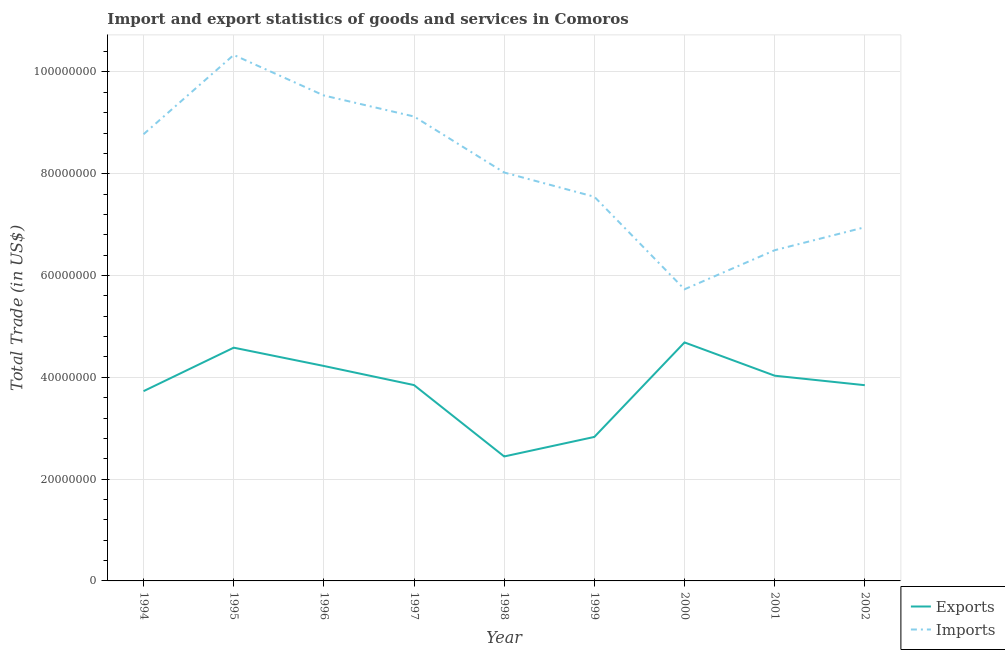Is the number of lines equal to the number of legend labels?
Offer a terse response. Yes. What is the export of goods and services in 1997?
Your answer should be very brief. 3.85e+07. Across all years, what is the maximum imports of goods and services?
Make the answer very short. 1.03e+08. Across all years, what is the minimum imports of goods and services?
Give a very brief answer. 5.73e+07. In which year was the export of goods and services maximum?
Offer a very short reply. 2000. What is the total export of goods and services in the graph?
Offer a very short reply. 3.42e+08. What is the difference between the imports of goods and services in 1999 and that in 2000?
Your answer should be compact. 1.82e+07. What is the difference between the export of goods and services in 1997 and the imports of goods and services in 2002?
Ensure brevity in your answer.  -3.10e+07. What is the average export of goods and services per year?
Keep it short and to the point. 3.80e+07. In the year 2002, what is the difference between the imports of goods and services and export of goods and services?
Your response must be concise. 3.10e+07. What is the ratio of the export of goods and services in 1996 to that in 2000?
Provide a short and direct response. 0.9. Is the imports of goods and services in 1999 less than that in 2001?
Offer a very short reply. No. What is the difference between the highest and the second highest imports of goods and services?
Offer a very short reply. 7.97e+06. What is the difference between the highest and the lowest export of goods and services?
Your response must be concise. 2.24e+07. In how many years, is the imports of goods and services greater than the average imports of goods and services taken over all years?
Keep it short and to the point. 4. Is the sum of the export of goods and services in 1997 and 2000 greater than the maximum imports of goods and services across all years?
Your answer should be compact. No. Is the export of goods and services strictly greater than the imports of goods and services over the years?
Your answer should be very brief. No. Is the imports of goods and services strictly less than the export of goods and services over the years?
Keep it short and to the point. No. How many lines are there?
Your response must be concise. 2. What is the difference between two consecutive major ticks on the Y-axis?
Make the answer very short. 2.00e+07. Are the values on the major ticks of Y-axis written in scientific E-notation?
Make the answer very short. No. Does the graph contain any zero values?
Provide a short and direct response. No. How many legend labels are there?
Provide a short and direct response. 2. What is the title of the graph?
Keep it short and to the point. Import and export statistics of goods and services in Comoros. What is the label or title of the Y-axis?
Give a very brief answer. Total Trade (in US$). What is the Total Trade (in US$) in Exports in 1994?
Ensure brevity in your answer.  3.73e+07. What is the Total Trade (in US$) in Imports in 1994?
Your answer should be very brief. 8.78e+07. What is the Total Trade (in US$) in Exports in 1995?
Ensure brevity in your answer.  4.58e+07. What is the Total Trade (in US$) of Imports in 1995?
Give a very brief answer. 1.03e+08. What is the Total Trade (in US$) of Exports in 1996?
Offer a terse response. 4.22e+07. What is the Total Trade (in US$) of Imports in 1996?
Your answer should be compact. 9.54e+07. What is the Total Trade (in US$) in Exports in 1997?
Make the answer very short. 3.85e+07. What is the Total Trade (in US$) of Imports in 1997?
Give a very brief answer. 9.13e+07. What is the Total Trade (in US$) in Exports in 1998?
Ensure brevity in your answer.  2.45e+07. What is the Total Trade (in US$) in Imports in 1998?
Your response must be concise. 8.02e+07. What is the Total Trade (in US$) in Exports in 1999?
Provide a short and direct response. 2.83e+07. What is the Total Trade (in US$) of Imports in 1999?
Your answer should be compact. 7.55e+07. What is the Total Trade (in US$) in Exports in 2000?
Offer a terse response. 4.69e+07. What is the Total Trade (in US$) in Imports in 2000?
Provide a succinct answer. 5.73e+07. What is the Total Trade (in US$) in Exports in 2001?
Keep it short and to the point. 4.03e+07. What is the Total Trade (in US$) in Imports in 2001?
Ensure brevity in your answer.  6.50e+07. What is the Total Trade (in US$) in Exports in 2002?
Give a very brief answer. 3.85e+07. What is the Total Trade (in US$) of Imports in 2002?
Ensure brevity in your answer.  6.95e+07. Across all years, what is the maximum Total Trade (in US$) in Exports?
Give a very brief answer. 4.69e+07. Across all years, what is the maximum Total Trade (in US$) of Imports?
Offer a terse response. 1.03e+08. Across all years, what is the minimum Total Trade (in US$) in Exports?
Provide a short and direct response. 2.45e+07. Across all years, what is the minimum Total Trade (in US$) of Imports?
Keep it short and to the point. 5.73e+07. What is the total Total Trade (in US$) in Exports in the graph?
Your response must be concise. 3.42e+08. What is the total Total Trade (in US$) of Imports in the graph?
Offer a terse response. 7.25e+08. What is the difference between the Total Trade (in US$) in Exports in 1994 and that in 1995?
Provide a succinct answer. -8.54e+06. What is the difference between the Total Trade (in US$) in Imports in 1994 and that in 1995?
Provide a succinct answer. -1.56e+07. What is the difference between the Total Trade (in US$) of Exports in 1994 and that in 1996?
Keep it short and to the point. -4.95e+06. What is the difference between the Total Trade (in US$) in Imports in 1994 and that in 1996?
Your response must be concise. -7.61e+06. What is the difference between the Total Trade (in US$) in Exports in 1994 and that in 1997?
Offer a very short reply. -1.19e+06. What is the difference between the Total Trade (in US$) in Imports in 1994 and that in 1997?
Give a very brief answer. -3.48e+06. What is the difference between the Total Trade (in US$) of Exports in 1994 and that in 1998?
Your answer should be very brief. 1.28e+07. What is the difference between the Total Trade (in US$) of Imports in 1994 and that in 1998?
Your response must be concise. 7.52e+06. What is the difference between the Total Trade (in US$) of Exports in 1994 and that in 1999?
Offer a very short reply. 9.00e+06. What is the difference between the Total Trade (in US$) of Imports in 1994 and that in 1999?
Your answer should be very brief. 1.23e+07. What is the difference between the Total Trade (in US$) in Exports in 1994 and that in 2000?
Your response must be concise. -9.57e+06. What is the difference between the Total Trade (in US$) in Imports in 1994 and that in 2000?
Keep it short and to the point. 3.05e+07. What is the difference between the Total Trade (in US$) in Exports in 1994 and that in 2001?
Keep it short and to the point. -3.04e+06. What is the difference between the Total Trade (in US$) of Imports in 1994 and that in 2001?
Provide a short and direct response. 2.28e+07. What is the difference between the Total Trade (in US$) in Exports in 1994 and that in 2002?
Ensure brevity in your answer.  -1.17e+06. What is the difference between the Total Trade (in US$) in Imports in 1994 and that in 2002?
Your answer should be compact. 1.83e+07. What is the difference between the Total Trade (in US$) of Exports in 1995 and that in 1996?
Make the answer very short. 3.60e+06. What is the difference between the Total Trade (in US$) in Imports in 1995 and that in 1996?
Your answer should be very brief. 7.97e+06. What is the difference between the Total Trade (in US$) in Exports in 1995 and that in 1997?
Ensure brevity in your answer.  7.35e+06. What is the difference between the Total Trade (in US$) in Imports in 1995 and that in 1997?
Offer a very short reply. 1.21e+07. What is the difference between the Total Trade (in US$) of Exports in 1995 and that in 1998?
Ensure brevity in your answer.  2.14e+07. What is the difference between the Total Trade (in US$) in Imports in 1995 and that in 1998?
Offer a very short reply. 2.31e+07. What is the difference between the Total Trade (in US$) in Exports in 1995 and that in 1999?
Keep it short and to the point. 1.75e+07. What is the difference between the Total Trade (in US$) of Imports in 1995 and that in 1999?
Your answer should be very brief. 2.79e+07. What is the difference between the Total Trade (in US$) of Exports in 1995 and that in 2000?
Offer a terse response. -1.03e+06. What is the difference between the Total Trade (in US$) of Imports in 1995 and that in 2000?
Your response must be concise. 4.60e+07. What is the difference between the Total Trade (in US$) in Exports in 1995 and that in 2001?
Offer a very short reply. 5.51e+06. What is the difference between the Total Trade (in US$) in Imports in 1995 and that in 2001?
Your answer should be compact. 3.84e+07. What is the difference between the Total Trade (in US$) in Exports in 1995 and that in 2002?
Provide a succinct answer. 7.37e+06. What is the difference between the Total Trade (in US$) of Imports in 1995 and that in 2002?
Provide a short and direct response. 3.39e+07. What is the difference between the Total Trade (in US$) of Exports in 1996 and that in 1997?
Offer a terse response. 3.75e+06. What is the difference between the Total Trade (in US$) in Imports in 1996 and that in 1997?
Your answer should be very brief. 4.13e+06. What is the difference between the Total Trade (in US$) of Exports in 1996 and that in 1998?
Offer a very short reply. 1.78e+07. What is the difference between the Total Trade (in US$) in Imports in 1996 and that in 1998?
Your response must be concise. 1.51e+07. What is the difference between the Total Trade (in US$) of Exports in 1996 and that in 1999?
Offer a terse response. 1.39e+07. What is the difference between the Total Trade (in US$) in Imports in 1996 and that in 1999?
Give a very brief answer. 1.99e+07. What is the difference between the Total Trade (in US$) in Exports in 1996 and that in 2000?
Your answer should be compact. -4.63e+06. What is the difference between the Total Trade (in US$) of Imports in 1996 and that in 2000?
Your answer should be very brief. 3.81e+07. What is the difference between the Total Trade (in US$) in Exports in 1996 and that in 2001?
Your answer should be very brief. 1.91e+06. What is the difference between the Total Trade (in US$) in Imports in 1996 and that in 2001?
Offer a terse response. 3.04e+07. What is the difference between the Total Trade (in US$) in Exports in 1996 and that in 2002?
Offer a terse response. 3.78e+06. What is the difference between the Total Trade (in US$) of Imports in 1996 and that in 2002?
Your answer should be very brief. 2.59e+07. What is the difference between the Total Trade (in US$) in Exports in 1997 and that in 1998?
Your answer should be very brief. 1.40e+07. What is the difference between the Total Trade (in US$) in Imports in 1997 and that in 1998?
Make the answer very short. 1.10e+07. What is the difference between the Total Trade (in US$) of Exports in 1997 and that in 1999?
Provide a succinct answer. 1.02e+07. What is the difference between the Total Trade (in US$) of Imports in 1997 and that in 1999?
Provide a succinct answer. 1.58e+07. What is the difference between the Total Trade (in US$) of Exports in 1997 and that in 2000?
Make the answer very short. -8.38e+06. What is the difference between the Total Trade (in US$) in Imports in 1997 and that in 2000?
Ensure brevity in your answer.  3.40e+07. What is the difference between the Total Trade (in US$) in Exports in 1997 and that in 2001?
Offer a terse response. -1.84e+06. What is the difference between the Total Trade (in US$) in Imports in 1997 and that in 2001?
Give a very brief answer. 2.63e+07. What is the difference between the Total Trade (in US$) in Exports in 1997 and that in 2002?
Give a very brief answer. 2.23e+04. What is the difference between the Total Trade (in US$) in Imports in 1997 and that in 2002?
Offer a terse response. 2.18e+07. What is the difference between the Total Trade (in US$) in Exports in 1998 and that in 1999?
Offer a very short reply. -3.84e+06. What is the difference between the Total Trade (in US$) in Imports in 1998 and that in 1999?
Provide a succinct answer. 4.76e+06. What is the difference between the Total Trade (in US$) of Exports in 1998 and that in 2000?
Ensure brevity in your answer.  -2.24e+07. What is the difference between the Total Trade (in US$) in Imports in 1998 and that in 2000?
Give a very brief answer. 2.29e+07. What is the difference between the Total Trade (in US$) in Exports in 1998 and that in 2001?
Keep it short and to the point. -1.59e+07. What is the difference between the Total Trade (in US$) of Imports in 1998 and that in 2001?
Keep it short and to the point. 1.53e+07. What is the difference between the Total Trade (in US$) in Exports in 1998 and that in 2002?
Make the answer very short. -1.40e+07. What is the difference between the Total Trade (in US$) of Imports in 1998 and that in 2002?
Your answer should be very brief. 1.08e+07. What is the difference between the Total Trade (in US$) in Exports in 1999 and that in 2000?
Offer a terse response. -1.86e+07. What is the difference between the Total Trade (in US$) in Imports in 1999 and that in 2000?
Offer a very short reply. 1.82e+07. What is the difference between the Total Trade (in US$) in Exports in 1999 and that in 2001?
Your answer should be compact. -1.20e+07. What is the difference between the Total Trade (in US$) of Imports in 1999 and that in 2001?
Your response must be concise. 1.05e+07. What is the difference between the Total Trade (in US$) of Exports in 1999 and that in 2002?
Give a very brief answer. -1.02e+07. What is the difference between the Total Trade (in US$) of Imports in 1999 and that in 2002?
Your answer should be very brief. 5.99e+06. What is the difference between the Total Trade (in US$) of Exports in 2000 and that in 2001?
Offer a terse response. 6.54e+06. What is the difference between the Total Trade (in US$) of Imports in 2000 and that in 2001?
Give a very brief answer. -7.68e+06. What is the difference between the Total Trade (in US$) in Exports in 2000 and that in 2002?
Give a very brief answer. 8.40e+06. What is the difference between the Total Trade (in US$) of Imports in 2000 and that in 2002?
Provide a succinct answer. -1.22e+07. What is the difference between the Total Trade (in US$) in Exports in 2001 and that in 2002?
Your answer should be compact. 1.87e+06. What is the difference between the Total Trade (in US$) of Imports in 2001 and that in 2002?
Keep it short and to the point. -4.51e+06. What is the difference between the Total Trade (in US$) of Exports in 1994 and the Total Trade (in US$) of Imports in 1995?
Provide a succinct answer. -6.61e+07. What is the difference between the Total Trade (in US$) in Exports in 1994 and the Total Trade (in US$) in Imports in 1996?
Offer a terse response. -5.81e+07. What is the difference between the Total Trade (in US$) of Exports in 1994 and the Total Trade (in US$) of Imports in 1997?
Ensure brevity in your answer.  -5.40e+07. What is the difference between the Total Trade (in US$) in Exports in 1994 and the Total Trade (in US$) in Imports in 1998?
Your answer should be compact. -4.30e+07. What is the difference between the Total Trade (in US$) of Exports in 1994 and the Total Trade (in US$) of Imports in 1999?
Ensure brevity in your answer.  -3.82e+07. What is the difference between the Total Trade (in US$) of Exports in 1994 and the Total Trade (in US$) of Imports in 2000?
Keep it short and to the point. -2.00e+07. What is the difference between the Total Trade (in US$) of Exports in 1994 and the Total Trade (in US$) of Imports in 2001?
Provide a succinct answer. -2.77e+07. What is the difference between the Total Trade (in US$) in Exports in 1994 and the Total Trade (in US$) in Imports in 2002?
Offer a terse response. -3.22e+07. What is the difference between the Total Trade (in US$) of Exports in 1995 and the Total Trade (in US$) of Imports in 1996?
Provide a short and direct response. -4.96e+07. What is the difference between the Total Trade (in US$) of Exports in 1995 and the Total Trade (in US$) of Imports in 1997?
Provide a short and direct response. -4.54e+07. What is the difference between the Total Trade (in US$) in Exports in 1995 and the Total Trade (in US$) in Imports in 1998?
Your response must be concise. -3.44e+07. What is the difference between the Total Trade (in US$) in Exports in 1995 and the Total Trade (in US$) in Imports in 1999?
Ensure brevity in your answer.  -2.97e+07. What is the difference between the Total Trade (in US$) in Exports in 1995 and the Total Trade (in US$) in Imports in 2000?
Give a very brief answer. -1.15e+07. What is the difference between the Total Trade (in US$) of Exports in 1995 and the Total Trade (in US$) of Imports in 2001?
Make the answer very short. -1.91e+07. What is the difference between the Total Trade (in US$) in Exports in 1995 and the Total Trade (in US$) in Imports in 2002?
Keep it short and to the point. -2.37e+07. What is the difference between the Total Trade (in US$) of Exports in 1996 and the Total Trade (in US$) of Imports in 1997?
Provide a short and direct response. -4.90e+07. What is the difference between the Total Trade (in US$) of Exports in 1996 and the Total Trade (in US$) of Imports in 1998?
Provide a short and direct response. -3.80e+07. What is the difference between the Total Trade (in US$) of Exports in 1996 and the Total Trade (in US$) of Imports in 1999?
Offer a terse response. -3.32e+07. What is the difference between the Total Trade (in US$) of Exports in 1996 and the Total Trade (in US$) of Imports in 2000?
Offer a terse response. -1.51e+07. What is the difference between the Total Trade (in US$) in Exports in 1996 and the Total Trade (in US$) in Imports in 2001?
Provide a short and direct response. -2.27e+07. What is the difference between the Total Trade (in US$) of Exports in 1996 and the Total Trade (in US$) of Imports in 2002?
Ensure brevity in your answer.  -2.73e+07. What is the difference between the Total Trade (in US$) of Exports in 1997 and the Total Trade (in US$) of Imports in 1998?
Provide a succinct answer. -4.18e+07. What is the difference between the Total Trade (in US$) of Exports in 1997 and the Total Trade (in US$) of Imports in 1999?
Offer a very short reply. -3.70e+07. What is the difference between the Total Trade (in US$) in Exports in 1997 and the Total Trade (in US$) in Imports in 2000?
Provide a short and direct response. -1.88e+07. What is the difference between the Total Trade (in US$) of Exports in 1997 and the Total Trade (in US$) of Imports in 2001?
Provide a short and direct response. -2.65e+07. What is the difference between the Total Trade (in US$) of Exports in 1997 and the Total Trade (in US$) of Imports in 2002?
Provide a succinct answer. -3.10e+07. What is the difference between the Total Trade (in US$) of Exports in 1998 and the Total Trade (in US$) of Imports in 1999?
Offer a terse response. -5.10e+07. What is the difference between the Total Trade (in US$) in Exports in 1998 and the Total Trade (in US$) in Imports in 2000?
Your response must be concise. -3.28e+07. What is the difference between the Total Trade (in US$) of Exports in 1998 and the Total Trade (in US$) of Imports in 2001?
Your response must be concise. -4.05e+07. What is the difference between the Total Trade (in US$) in Exports in 1998 and the Total Trade (in US$) in Imports in 2002?
Provide a short and direct response. -4.50e+07. What is the difference between the Total Trade (in US$) of Exports in 1999 and the Total Trade (in US$) of Imports in 2000?
Make the answer very short. -2.90e+07. What is the difference between the Total Trade (in US$) of Exports in 1999 and the Total Trade (in US$) of Imports in 2001?
Provide a short and direct response. -3.67e+07. What is the difference between the Total Trade (in US$) of Exports in 1999 and the Total Trade (in US$) of Imports in 2002?
Provide a short and direct response. -4.12e+07. What is the difference between the Total Trade (in US$) of Exports in 2000 and the Total Trade (in US$) of Imports in 2001?
Your response must be concise. -1.81e+07. What is the difference between the Total Trade (in US$) in Exports in 2000 and the Total Trade (in US$) in Imports in 2002?
Offer a terse response. -2.26e+07. What is the difference between the Total Trade (in US$) of Exports in 2001 and the Total Trade (in US$) of Imports in 2002?
Provide a short and direct response. -2.92e+07. What is the average Total Trade (in US$) in Exports per year?
Ensure brevity in your answer.  3.80e+07. What is the average Total Trade (in US$) in Imports per year?
Keep it short and to the point. 8.06e+07. In the year 1994, what is the difference between the Total Trade (in US$) in Exports and Total Trade (in US$) in Imports?
Give a very brief answer. -5.05e+07. In the year 1995, what is the difference between the Total Trade (in US$) of Exports and Total Trade (in US$) of Imports?
Make the answer very short. -5.75e+07. In the year 1996, what is the difference between the Total Trade (in US$) of Exports and Total Trade (in US$) of Imports?
Provide a short and direct response. -5.31e+07. In the year 1997, what is the difference between the Total Trade (in US$) of Exports and Total Trade (in US$) of Imports?
Offer a terse response. -5.28e+07. In the year 1998, what is the difference between the Total Trade (in US$) in Exports and Total Trade (in US$) in Imports?
Your answer should be very brief. -5.58e+07. In the year 1999, what is the difference between the Total Trade (in US$) in Exports and Total Trade (in US$) in Imports?
Offer a very short reply. -4.72e+07. In the year 2000, what is the difference between the Total Trade (in US$) in Exports and Total Trade (in US$) in Imports?
Offer a terse response. -1.04e+07. In the year 2001, what is the difference between the Total Trade (in US$) in Exports and Total Trade (in US$) in Imports?
Provide a succinct answer. -2.47e+07. In the year 2002, what is the difference between the Total Trade (in US$) in Exports and Total Trade (in US$) in Imports?
Your answer should be compact. -3.10e+07. What is the ratio of the Total Trade (in US$) of Exports in 1994 to that in 1995?
Make the answer very short. 0.81. What is the ratio of the Total Trade (in US$) of Imports in 1994 to that in 1995?
Offer a terse response. 0.85. What is the ratio of the Total Trade (in US$) in Exports in 1994 to that in 1996?
Provide a short and direct response. 0.88. What is the ratio of the Total Trade (in US$) in Imports in 1994 to that in 1996?
Provide a succinct answer. 0.92. What is the ratio of the Total Trade (in US$) of Exports in 1994 to that in 1997?
Make the answer very short. 0.97. What is the ratio of the Total Trade (in US$) in Imports in 1994 to that in 1997?
Keep it short and to the point. 0.96. What is the ratio of the Total Trade (in US$) of Exports in 1994 to that in 1998?
Keep it short and to the point. 1.52. What is the ratio of the Total Trade (in US$) in Imports in 1994 to that in 1998?
Make the answer very short. 1.09. What is the ratio of the Total Trade (in US$) of Exports in 1994 to that in 1999?
Make the answer very short. 1.32. What is the ratio of the Total Trade (in US$) in Imports in 1994 to that in 1999?
Give a very brief answer. 1.16. What is the ratio of the Total Trade (in US$) of Exports in 1994 to that in 2000?
Offer a terse response. 0.8. What is the ratio of the Total Trade (in US$) in Imports in 1994 to that in 2000?
Provide a succinct answer. 1.53. What is the ratio of the Total Trade (in US$) in Exports in 1994 to that in 2001?
Offer a terse response. 0.92. What is the ratio of the Total Trade (in US$) in Imports in 1994 to that in 2001?
Offer a terse response. 1.35. What is the ratio of the Total Trade (in US$) of Exports in 1994 to that in 2002?
Your answer should be compact. 0.97. What is the ratio of the Total Trade (in US$) of Imports in 1994 to that in 2002?
Give a very brief answer. 1.26. What is the ratio of the Total Trade (in US$) in Exports in 1995 to that in 1996?
Give a very brief answer. 1.09. What is the ratio of the Total Trade (in US$) of Imports in 1995 to that in 1996?
Keep it short and to the point. 1.08. What is the ratio of the Total Trade (in US$) of Exports in 1995 to that in 1997?
Your response must be concise. 1.19. What is the ratio of the Total Trade (in US$) of Imports in 1995 to that in 1997?
Provide a succinct answer. 1.13. What is the ratio of the Total Trade (in US$) of Exports in 1995 to that in 1998?
Keep it short and to the point. 1.87. What is the ratio of the Total Trade (in US$) of Imports in 1995 to that in 1998?
Offer a terse response. 1.29. What is the ratio of the Total Trade (in US$) in Exports in 1995 to that in 1999?
Ensure brevity in your answer.  1.62. What is the ratio of the Total Trade (in US$) of Imports in 1995 to that in 1999?
Give a very brief answer. 1.37. What is the ratio of the Total Trade (in US$) in Imports in 1995 to that in 2000?
Keep it short and to the point. 1.8. What is the ratio of the Total Trade (in US$) of Exports in 1995 to that in 2001?
Provide a short and direct response. 1.14. What is the ratio of the Total Trade (in US$) in Imports in 1995 to that in 2001?
Offer a very short reply. 1.59. What is the ratio of the Total Trade (in US$) in Exports in 1995 to that in 2002?
Give a very brief answer. 1.19. What is the ratio of the Total Trade (in US$) in Imports in 1995 to that in 2002?
Keep it short and to the point. 1.49. What is the ratio of the Total Trade (in US$) in Exports in 1996 to that in 1997?
Your answer should be very brief. 1.1. What is the ratio of the Total Trade (in US$) in Imports in 1996 to that in 1997?
Provide a short and direct response. 1.05. What is the ratio of the Total Trade (in US$) of Exports in 1996 to that in 1998?
Keep it short and to the point. 1.73. What is the ratio of the Total Trade (in US$) in Imports in 1996 to that in 1998?
Provide a succinct answer. 1.19. What is the ratio of the Total Trade (in US$) of Exports in 1996 to that in 1999?
Ensure brevity in your answer.  1.49. What is the ratio of the Total Trade (in US$) of Imports in 1996 to that in 1999?
Give a very brief answer. 1.26. What is the ratio of the Total Trade (in US$) in Exports in 1996 to that in 2000?
Your response must be concise. 0.9. What is the ratio of the Total Trade (in US$) in Imports in 1996 to that in 2000?
Provide a succinct answer. 1.66. What is the ratio of the Total Trade (in US$) in Exports in 1996 to that in 2001?
Your answer should be very brief. 1.05. What is the ratio of the Total Trade (in US$) in Imports in 1996 to that in 2001?
Your response must be concise. 1.47. What is the ratio of the Total Trade (in US$) in Exports in 1996 to that in 2002?
Your answer should be compact. 1.1. What is the ratio of the Total Trade (in US$) in Imports in 1996 to that in 2002?
Provide a succinct answer. 1.37. What is the ratio of the Total Trade (in US$) in Exports in 1997 to that in 1998?
Your response must be concise. 1.57. What is the ratio of the Total Trade (in US$) in Imports in 1997 to that in 1998?
Keep it short and to the point. 1.14. What is the ratio of the Total Trade (in US$) in Exports in 1997 to that in 1999?
Provide a succinct answer. 1.36. What is the ratio of the Total Trade (in US$) in Imports in 1997 to that in 1999?
Provide a short and direct response. 1.21. What is the ratio of the Total Trade (in US$) of Exports in 1997 to that in 2000?
Offer a terse response. 0.82. What is the ratio of the Total Trade (in US$) in Imports in 1997 to that in 2000?
Make the answer very short. 1.59. What is the ratio of the Total Trade (in US$) in Exports in 1997 to that in 2001?
Provide a succinct answer. 0.95. What is the ratio of the Total Trade (in US$) of Imports in 1997 to that in 2001?
Make the answer very short. 1.4. What is the ratio of the Total Trade (in US$) of Exports in 1997 to that in 2002?
Keep it short and to the point. 1. What is the ratio of the Total Trade (in US$) in Imports in 1997 to that in 2002?
Offer a terse response. 1.31. What is the ratio of the Total Trade (in US$) of Exports in 1998 to that in 1999?
Your response must be concise. 0.86. What is the ratio of the Total Trade (in US$) of Imports in 1998 to that in 1999?
Your answer should be very brief. 1.06. What is the ratio of the Total Trade (in US$) in Exports in 1998 to that in 2000?
Your answer should be very brief. 0.52. What is the ratio of the Total Trade (in US$) in Imports in 1998 to that in 2000?
Give a very brief answer. 1.4. What is the ratio of the Total Trade (in US$) of Exports in 1998 to that in 2001?
Make the answer very short. 0.61. What is the ratio of the Total Trade (in US$) of Imports in 1998 to that in 2001?
Keep it short and to the point. 1.24. What is the ratio of the Total Trade (in US$) of Exports in 1998 to that in 2002?
Your response must be concise. 0.64. What is the ratio of the Total Trade (in US$) in Imports in 1998 to that in 2002?
Make the answer very short. 1.15. What is the ratio of the Total Trade (in US$) of Exports in 1999 to that in 2000?
Make the answer very short. 0.6. What is the ratio of the Total Trade (in US$) in Imports in 1999 to that in 2000?
Your response must be concise. 1.32. What is the ratio of the Total Trade (in US$) of Exports in 1999 to that in 2001?
Make the answer very short. 0.7. What is the ratio of the Total Trade (in US$) of Imports in 1999 to that in 2001?
Give a very brief answer. 1.16. What is the ratio of the Total Trade (in US$) of Exports in 1999 to that in 2002?
Your answer should be very brief. 0.74. What is the ratio of the Total Trade (in US$) in Imports in 1999 to that in 2002?
Make the answer very short. 1.09. What is the ratio of the Total Trade (in US$) in Exports in 2000 to that in 2001?
Offer a very short reply. 1.16. What is the ratio of the Total Trade (in US$) of Imports in 2000 to that in 2001?
Offer a terse response. 0.88. What is the ratio of the Total Trade (in US$) in Exports in 2000 to that in 2002?
Give a very brief answer. 1.22. What is the ratio of the Total Trade (in US$) of Imports in 2000 to that in 2002?
Offer a terse response. 0.82. What is the ratio of the Total Trade (in US$) of Exports in 2001 to that in 2002?
Keep it short and to the point. 1.05. What is the ratio of the Total Trade (in US$) of Imports in 2001 to that in 2002?
Provide a succinct answer. 0.94. What is the difference between the highest and the second highest Total Trade (in US$) of Exports?
Your answer should be compact. 1.03e+06. What is the difference between the highest and the second highest Total Trade (in US$) in Imports?
Your answer should be compact. 7.97e+06. What is the difference between the highest and the lowest Total Trade (in US$) of Exports?
Make the answer very short. 2.24e+07. What is the difference between the highest and the lowest Total Trade (in US$) in Imports?
Make the answer very short. 4.60e+07. 